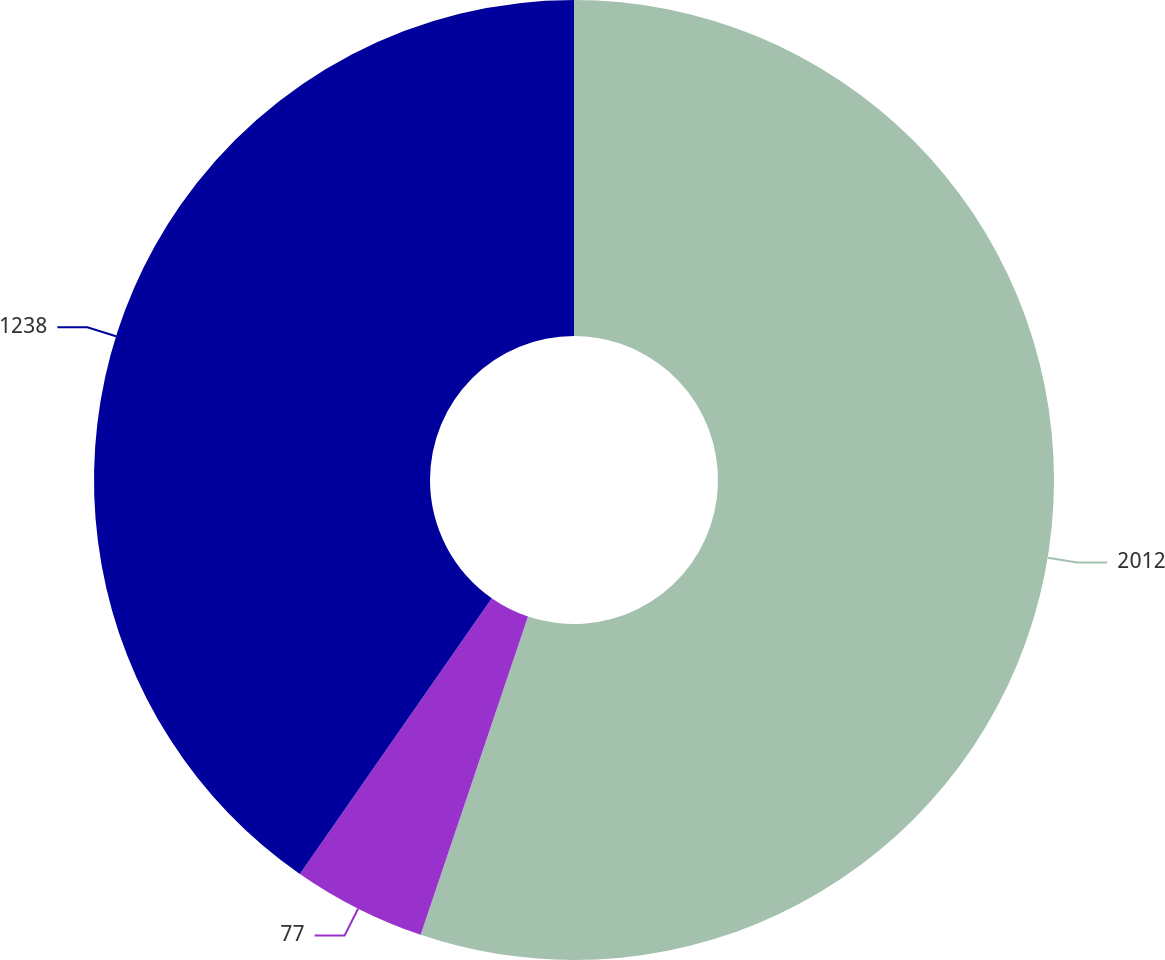Convert chart. <chart><loc_0><loc_0><loc_500><loc_500><pie_chart><fcel>2012<fcel>77<fcel>1238<nl><fcel>55.17%<fcel>4.5%<fcel>40.32%<nl></chart> 